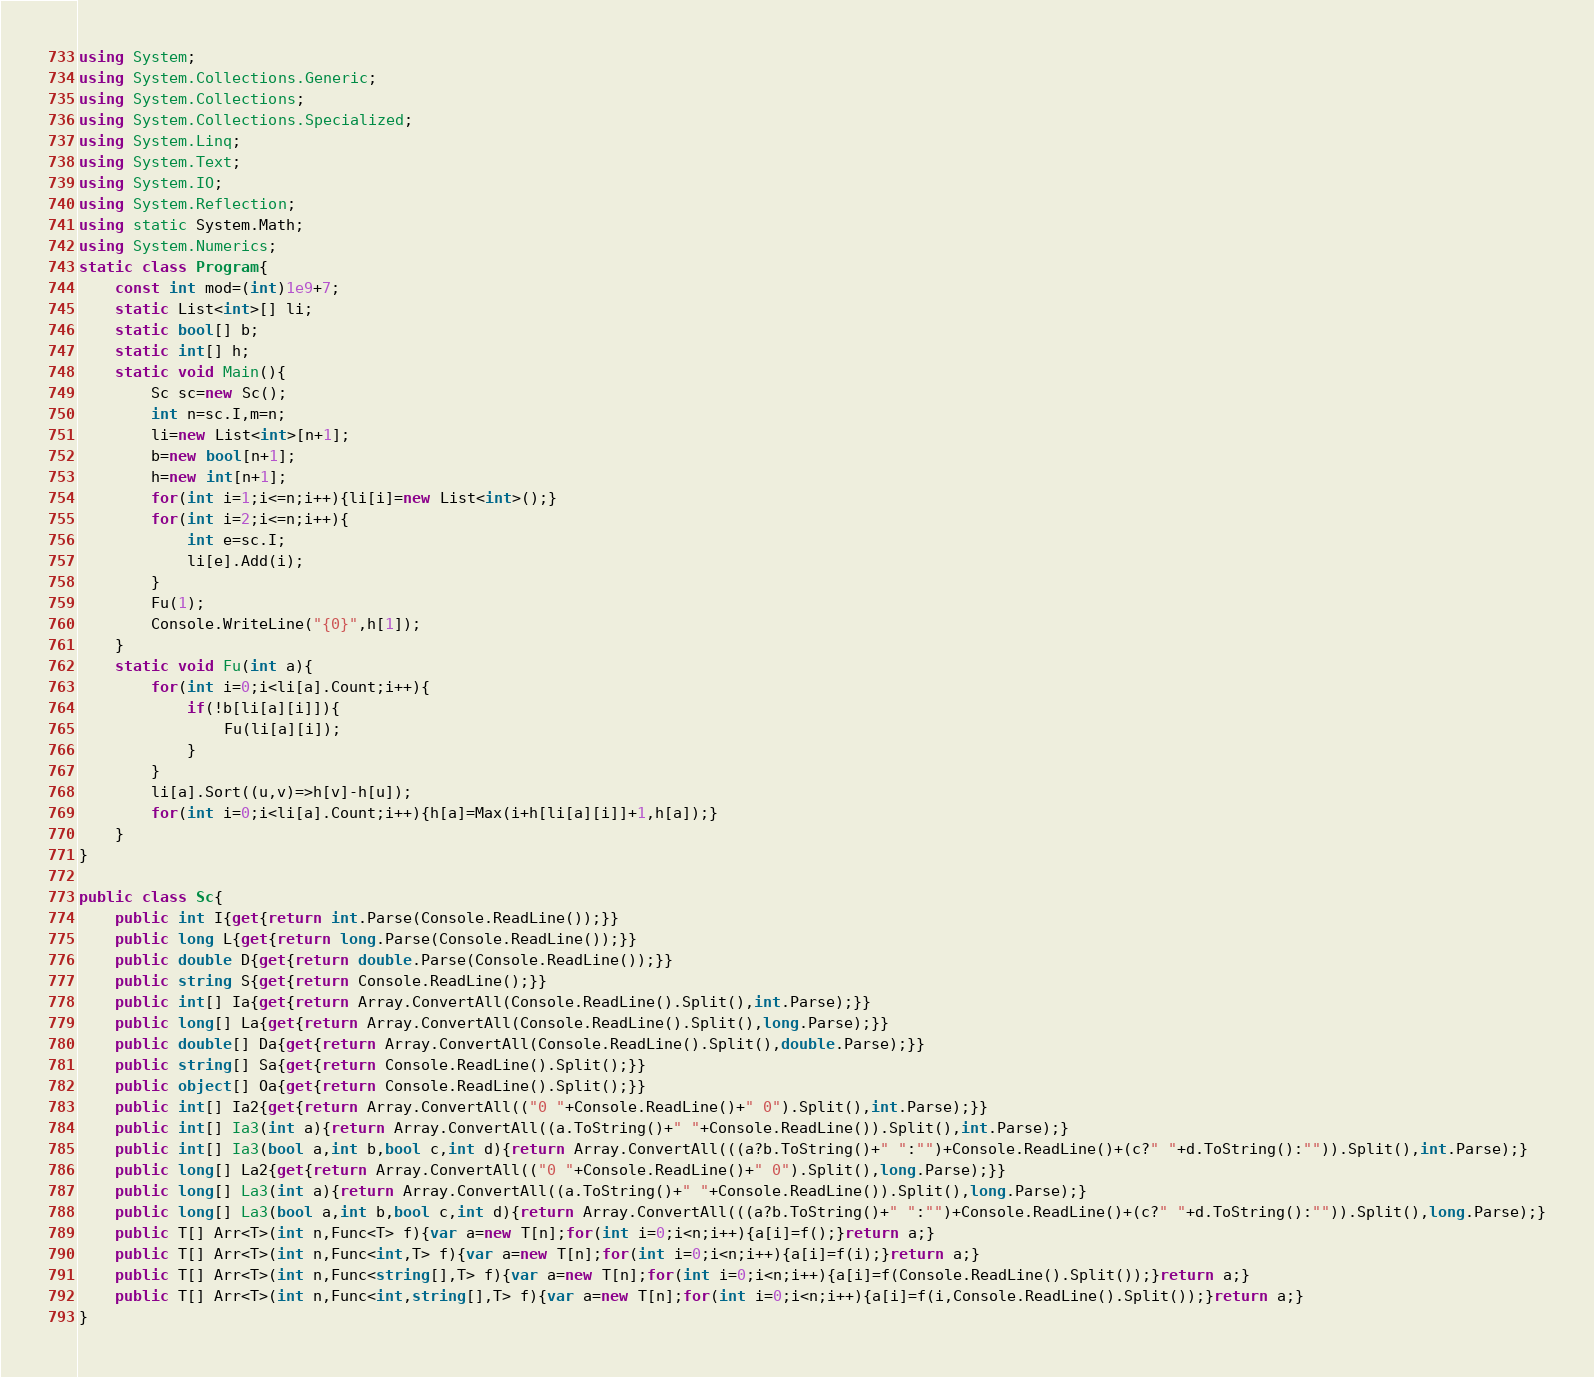<code> <loc_0><loc_0><loc_500><loc_500><_C#_>using System;
using System.Collections.Generic;
using System.Collections;
using System.Collections.Specialized;
using System.Linq;
using System.Text;
using System.IO;
using System.Reflection;
using static System.Math;
using System.Numerics;
static class Program{
	const int mod=(int)1e9+7;
	static List<int>[] li;
	static bool[] b;
	static int[] h;
	static void Main(){
		Sc sc=new Sc();
		int n=sc.I,m=n;
		li=new List<int>[n+1];
		b=new bool[n+1];
		h=new int[n+1];
		for(int i=1;i<=n;i++){li[i]=new List<int>();}
		for(int i=2;i<=n;i++){
			int e=sc.I;
			li[e].Add(i);
		}
		Fu(1);
		Console.WriteLine("{0}",h[1]);
	}
	static void Fu(int a){
		for(int i=0;i<li[a].Count;i++){
			if(!b[li[a][i]]){
				Fu(li[a][i]);
			}
		}
		li[a].Sort((u,v)=>h[v]-h[u]);
		for(int i=0;i<li[a].Count;i++){h[a]=Max(i+h[li[a][i]]+1,h[a]);}
	}
}

public class Sc{
	public int I{get{return int.Parse(Console.ReadLine());}}
	public long L{get{return long.Parse(Console.ReadLine());}}
	public double D{get{return double.Parse(Console.ReadLine());}}
	public string S{get{return Console.ReadLine();}}
	public int[] Ia{get{return Array.ConvertAll(Console.ReadLine().Split(),int.Parse);}}
	public long[] La{get{return Array.ConvertAll(Console.ReadLine().Split(),long.Parse);}}
	public double[] Da{get{return Array.ConvertAll(Console.ReadLine().Split(),double.Parse);}}
	public string[] Sa{get{return Console.ReadLine().Split();}}
	public object[] Oa{get{return Console.ReadLine().Split();}}
	public int[] Ia2{get{return Array.ConvertAll(("0 "+Console.ReadLine()+" 0").Split(),int.Parse);}}
	public int[] Ia3(int a){return Array.ConvertAll((a.ToString()+" "+Console.ReadLine()).Split(),int.Parse);}
	public int[] Ia3(bool a,int b,bool c,int d){return Array.ConvertAll(((a?b.ToString()+" ":"")+Console.ReadLine()+(c?" "+d.ToString():"")).Split(),int.Parse);}
	public long[] La2{get{return Array.ConvertAll(("0 "+Console.ReadLine()+" 0").Split(),long.Parse);}}
	public long[] La3(int a){return Array.ConvertAll((a.ToString()+" "+Console.ReadLine()).Split(),long.Parse);}
	public long[] La3(bool a,int b,bool c,int d){return Array.ConvertAll(((a?b.ToString()+" ":"")+Console.ReadLine()+(c?" "+d.ToString():"")).Split(),long.Parse);}
	public T[] Arr<T>(int n,Func<T> f){var a=new T[n];for(int i=0;i<n;i++){a[i]=f();}return a;}
	public T[] Arr<T>(int n,Func<int,T> f){var a=new T[n];for(int i=0;i<n;i++){a[i]=f(i);}return a;}
	public T[] Arr<T>(int n,Func<string[],T> f){var a=new T[n];for(int i=0;i<n;i++){a[i]=f(Console.ReadLine().Split());}return a;}
	public T[] Arr<T>(int n,Func<int,string[],T> f){var a=new T[n];for(int i=0;i<n;i++){a[i]=f(i,Console.ReadLine().Split());}return a;}
}</code> 